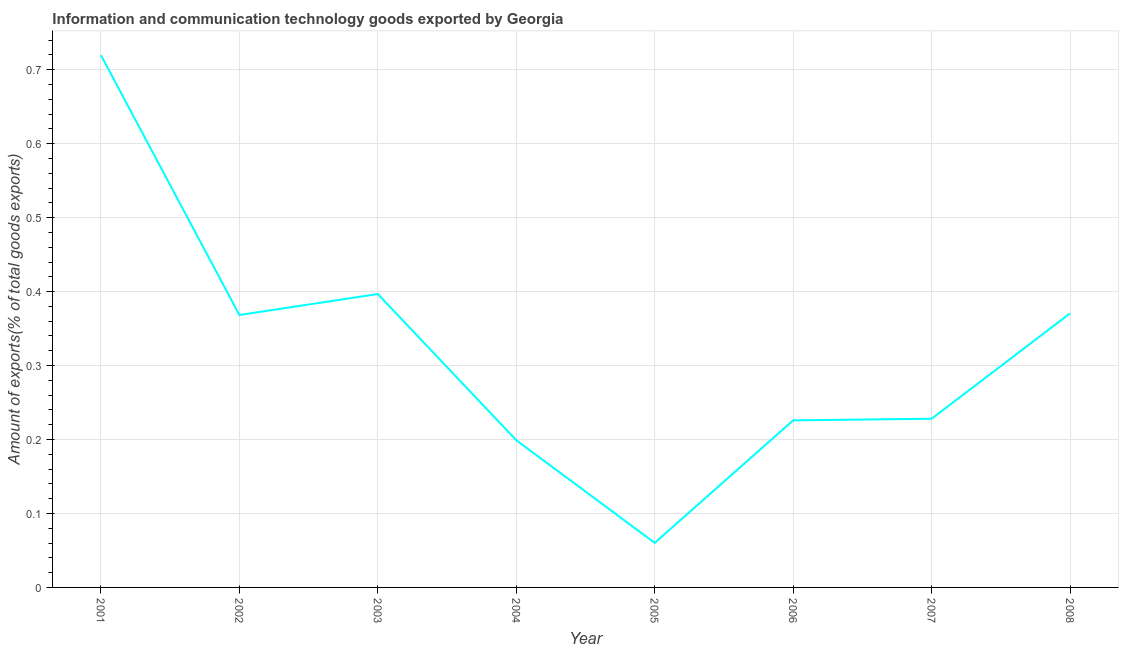What is the amount of ict goods exports in 2008?
Provide a succinct answer. 0.37. Across all years, what is the maximum amount of ict goods exports?
Give a very brief answer. 0.72. Across all years, what is the minimum amount of ict goods exports?
Make the answer very short. 0.06. What is the sum of the amount of ict goods exports?
Provide a succinct answer. 2.57. What is the difference between the amount of ict goods exports in 2002 and 2003?
Make the answer very short. -0.03. What is the average amount of ict goods exports per year?
Give a very brief answer. 0.32. What is the median amount of ict goods exports?
Your response must be concise. 0.3. Do a majority of the years between 2004 and 2005 (inclusive) have amount of ict goods exports greater than 0.12000000000000001 %?
Your answer should be very brief. No. What is the ratio of the amount of ict goods exports in 2005 to that in 2007?
Offer a terse response. 0.26. Is the difference between the amount of ict goods exports in 2002 and 2008 greater than the difference between any two years?
Your answer should be compact. No. What is the difference between the highest and the second highest amount of ict goods exports?
Make the answer very short. 0.32. What is the difference between the highest and the lowest amount of ict goods exports?
Your answer should be compact. 0.66. In how many years, is the amount of ict goods exports greater than the average amount of ict goods exports taken over all years?
Keep it short and to the point. 4. How many years are there in the graph?
Make the answer very short. 8. What is the difference between two consecutive major ticks on the Y-axis?
Your answer should be very brief. 0.1. Are the values on the major ticks of Y-axis written in scientific E-notation?
Keep it short and to the point. No. What is the title of the graph?
Give a very brief answer. Information and communication technology goods exported by Georgia. What is the label or title of the X-axis?
Keep it short and to the point. Year. What is the label or title of the Y-axis?
Your answer should be compact. Amount of exports(% of total goods exports). What is the Amount of exports(% of total goods exports) in 2001?
Make the answer very short. 0.72. What is the Amount of exports(% of total goods exports) of 2002?
Make the answer very short. 0.37. What is the Amount of exports(% of total goods exports) of 2003?
Offer a terse response. 0.4. What is the Amount of exports(% of total goods exports) of 2004?
Offer a very short reply. 0.2. What is the Amount of exports(% of total goods exports) of 2005?
Offer a very short reply. 0.06. What is the Amount of exports(% of total goods exports) of 2006?
Provide a succinct answer. 0.23. What is the Amount of exports(% of total goods exports) in 2007?
Offer a very short reply. 0.23. What is the Amount of exports(% of total goods exports) of 2008?
Your response must be concise. 0.37. What is the difference between the Amount of exports(% of total goods exports) in 2001 and 2002?
Your response must be concise. 0.35. What is the difference between the Amount of exports(% of total goods exports) in 2001 and 2003?
Your answer should be very brief. 0.32. What is the difference between the Amount of exports(% of total goods exports) in 2001 and 2004?
Keep it short and to the point. 0.52. What is the difference between the Amount of exports(% of total goods exports) in 2001 and 2005?
Keep it short and to the point. 0.66. What is the difference between the Amount of exports(% of total goods exports) in 2001 and 2006?
Your response must be concise. 0.49. What is the difference between the Amount of exports(% of total goods exports) in 2001 and 2007?
Make the answer very short. 0.49. What is the difference between the Amount of exports(% of total goods exports) in 2001 and 2008?
Your answer should be very brief. 0.35. What is the difference between the Amount of exports(% of total goods exports) in 2002 and 2003?
Provide a short and direct response. -0.03. What is the difference between the Amount of exports(% of total goods exports) in 2002 and 2004?
Your response must be concise. 0.17. What is the difference between the Amount of exports(% of total goods exports) in 2002 and 2005?
Provide a short and direct response. 0.31. What is the difference between the Amount of exports(% of total goods exports) in 2002 and 2006?
Your answer should be very brief. 0.14. What is the difference between the Amount of exports(% of total goods exports) in 2002 and 2007?
Keep it short and to the point. 0.14. What is the difference between the Amount of exports(% of total goods exports) in 2002 and 2008?
Your answer should be compact. -0. What is the difference between the Amount of exports(% of total goods exports) in 2003 and 2004?
Offer a terse response. 0.2. What is the difference between the Amount of exports(% of total goods exports) in 2003 and 2005?
Your answer should be compact. 0.34. What is the difference between the Amount of exports(% of total goods exports) in 2003 and 2006?
Keep it short and to the point. 0.17. What is the difference between the Amount of exports(% of total goods exports) in 2003 and 2007?
Offer a very short reply. 0.17. What is the difference between the Amount of exports(% of total goods exports) in 2003 and 2008?
Your response must be concise. 0.03. What is the difference between the Amount of exports(% of total goods exports) in 2004 and 2005?
Make the answer very short. 0.14. What is the difference between the Amount of exports(% of total goods exports) in 2004 and 2006?
Keep it short and to the point. -0.03. What is the difference between the Amount of exports(% of total goods exports) in 2004 and 2007?
Offer a terse response. -0.03. What is the difference between the Amount of exports(% of total goods exports) in 2004 and 2008?
Provide a succinct answer. -0.17. What is the difference between the Amount of exports(% of total goods exports) in 2005 and 2006?
Offer a very short reply. -0.17. What is the difference between the Amount of exports(% of total goods exports) in 2005 and 2007?
Your response must be concise. -0.17. What is the difference between the Amount of exports(% of total goods exports) in 2005 and 2008?
Provide a succinct answer. -0.31. What is the difference between the Amount of exports(% of total goods exports) in 2006 and 2007?
Offer a very short reply. -0. What is the difference between the Amount of exports(% of total goods exports) in 2006 and 2008?
Your answer should be very brief. -0.14. What is the difference between the Amount of exports(% of total goods exports) in 2007 and 2008?
Keep it short and to the point. -0.14. What is the ratio of the Amount of exports(% of total goods exports) in 2001 to that in 2002?
Make the answer very short. 1.95. What is the ratio of the Amount of exports(% of total goods exports) in 2001 to that in 2003?
Give a very brief answer. 1.81. What is the ratio of the Amount of exports(% of total goods exports) in 2001 to that in 2004?
Provide a succinct answer. 3.62. What is the ratio of the Amount of exports(% of total goods exports) in 2001 to that in 2005?
Your answer should be very brief. 11.95. What is the ratio of the Amount of exports(% of total goods exports) in 2001 to that in 2006?
Make the answer very short. 3.19. What is the ratio of the Amount of exports(% of total goods exports) in 2001 to that in 2007?
Provide a succinct answer. 3.15. What is the ratio of the Amount of exports(% of total goods exports) in 2001 to that in 2008?
Offer a terse response. 1.94. What is the ratio of the Amount of exports(% of total goods exports) in 2002 to that in 2003?
Keep it short and to the point. 0.93. What is the ratio of the Amount of exports(% of total goods exports) in 2002 to that in 2004?
Give a very brief answer. 1.85. What is the ratio of the Amount of exports(% of total goods exports) in 2002 to that in 2005?
Your answer should be very brief. 6.12. What is the ratio of the Amount of exports(% of total goods exports) in 2002 to that in 2006?
Ensure brevity in your answer.  1.63. What is the ratio of the Amount of exports(% of total goods exports) in 2002 to that in 2007?
Provide a succinct answer. 1.61. What is the ratio of the Amount of exports(% of total goods exports) in 2002 to that in 2008?
Your response must be concise. 0.99. What is the ratio of the Amount of exports(% of total goods exports) in 2003 to that in 2004?
Keep it short and to the point. 1.99. What is the ratio of the Amount of exports(% of total goods exports) in 2003 to that in 2005?
Offer a very short reply. 6.58. What is the ratio of the Amount of exports(% of total goods exports) in 2003 to that in 2006?
Give a very brief answer. 1.76. What is the ratio of the Amount of exports(% of total goods exports) in 2003 to that in 2007?
Offer a terse response. 1.74. What is the ratio of the Amount of exports(% of total goods exports) in 2003 to that in 2008?
Keep it short and to the point. 1.07. What is the ratio of the Amount of exports(% of total goods exports) in 2004 to that in 2005?
Your answer should be very brief. 3.3. What is the ratio of the Amount of exports(% of total goods exports) in 2004 to that in 2006?
Your answer should be compact. 0.88. What is the ratio of the Amount of exports(% of total goods exports) in 2004 to that in 2007?
Give a very brief answer. 0.87. What is the ratio of the Amount of exports(% of total goods exports) in 2004 to that in 2008?
Your answer should be very brief. 0.54. What is the ratio of the Amount of exports(% of total goods exports) in 2005 to that in 2006?
Provide a succinct answer. 0.27. What is the ratio of the Amount of exports(% of total goods exports) in 2005 to that in 2007?
Provide a succinct answer. 0.26. What is the ratio of the Amount of exports(% of total goods exports) in 2005 to that in 2008?
Provide a succinct answer. 0.16. What is the ratio of the Amount of exports(% of total goods exports) in 2006 to that in 2008?
Keep it short and to the point. 0.61. What is the ratio of the Amount of exports(% of total goods exports) in 2007 to that in 2008?
Give a very brief answer. 0.62. 